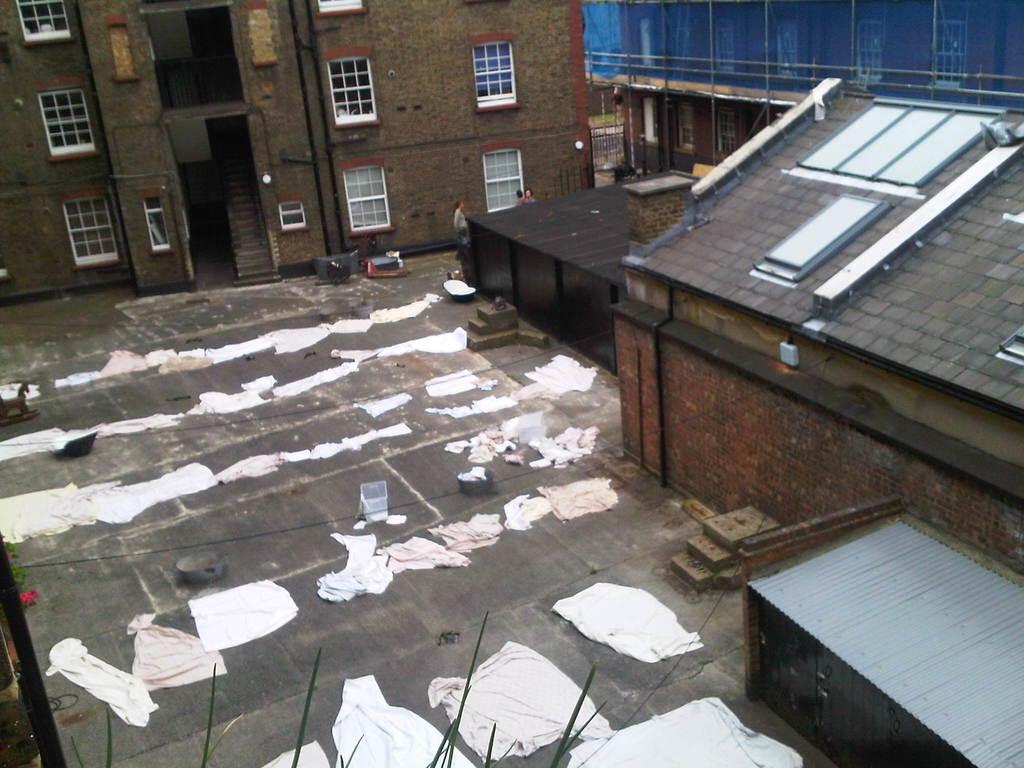Can you describe this image briefly? On the ground there are clothes. On the right side there are buildings. In the back there is a building with windows. 